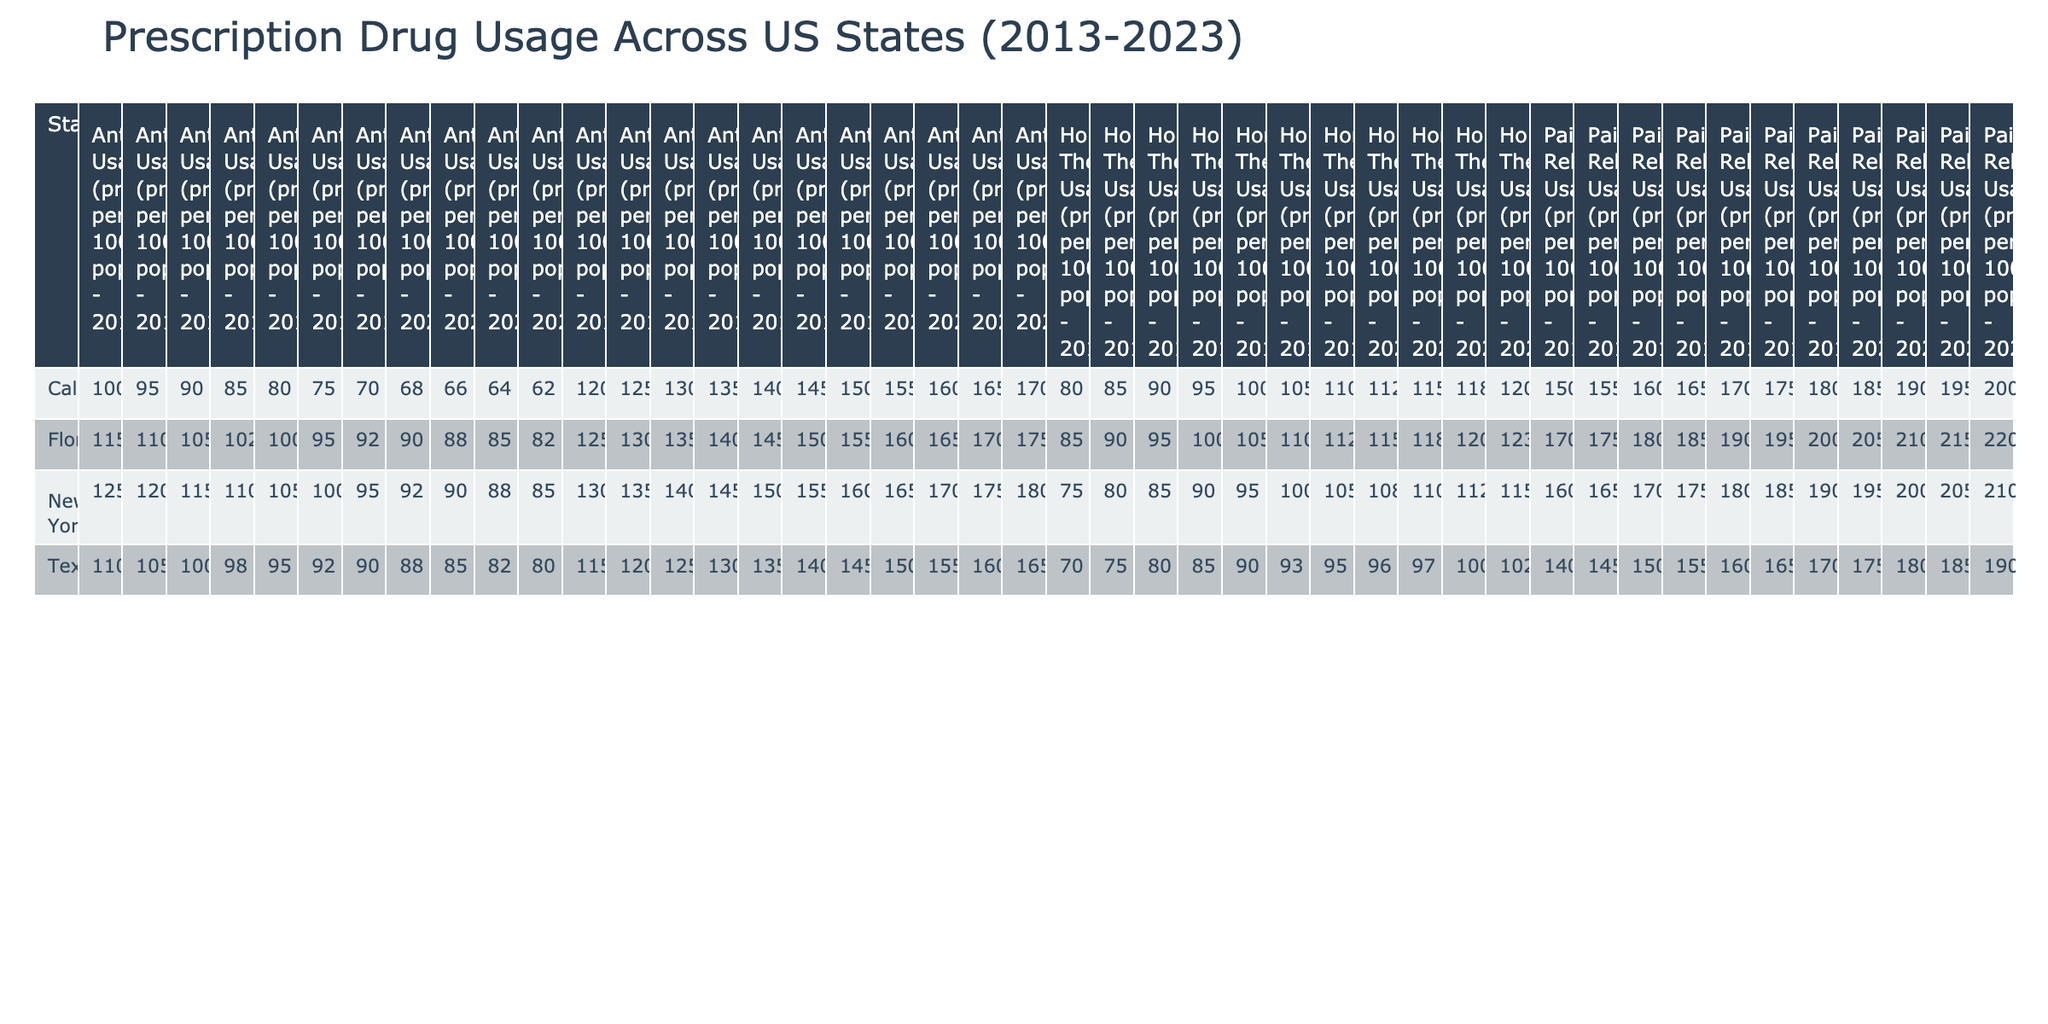What was the Pain Relievers Usage in New York in 2020? The table shows that the Pain Relievers Usage (prescriptions per 1000 population) in New York for the year 2020 is 195. This value can be directly retrieved from the New York row for that year.
Answer: 195 Which state had the highest Antibiotics Usage in 2015? From the table, Texas had an Antibiotics Usage of 100 prescriptions per 1000 population in 2015, while California had 90 and New York had 115. Comparing these values, New York has the highest at 115 prescriptions per 1000 population.
Answer: New York In which year did Florida have the highest Hormonal Therapy Usage? The table indicates Florida's Hormonal Therapy Usage from 2013 to 2023, which peaked in 2023 at 123 prescriptions per 1000 population. Checking the values row by row confirms this is the highest usage within the entire period.
Answer: 2023 What was the average Antidepressants Usage in California across the years? To find the average, sum the Antidepressants Usage values for California from 2013 to 2023, which are 120, 125, 130, 135, 140, 145, 150, 155, 160, 165, 170. The total is 1310, and with 11 years of data, the average is calculated as 1310/11, which equals approximately 119.09.
Answer: 139.09 Is the Pain Relievers Usage in California greater than that in Texas in 2017? By inspecting the table, California's Pain Relievers Usage in 2017 is 170 and Texas's is 160. Since 170 is greater than 160, the statement is true.
Answer: Yes Which state showed consistent increase in Antidepressants Usage over the decade? Reviewing the data, California starts with 120 in 2013 and consistently rises to 170 in 2023 without a decrease, indicating a uniform upward trend.
Answer: California What is the total Pain Relievers Usage across all states in 2022? The table reveals Pain Relievers Usage for each state in 2022: California (195), Texas (185), New York (205), and Florida (215). Summing these values gives 195 + 185 + 205 + 215 = 800 prescriptions per 1000 population total across all states for that year.
Answer: 800 In 2020, which state had the lowest Hormonal Therapy Usage? The table shows Florida's Hormonal Therapy Usage of 115 in 2020, Texas at 96, and California at 112. Comparing these values, Texas has the lowest Hormonal Therapy Usage for 2020 at 96 prescriptions per 1000 population.
Answer: Texas 